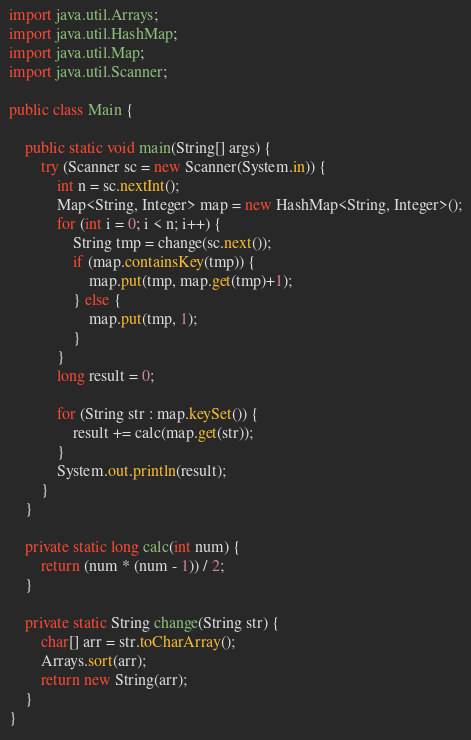Convert code to text. <code><loc_0><loc_0><loc_500><loc_500><_Java_>
import java.util.Arrays;
import java.util.HashMap;
import java.util.Map;
import java.util.Scanner;

public class Main {

	public static void main(String[] args) {
		try (Scanner sc = new Scanner(System.in)) {
			int n = sc.nextInt();
			Map<String, Integer> map = new HashMap<String, Integer>();
			for (int i = 0; i < n; i++) {
				String tmp = change(sc.next());
				if (map.containsKey(tmp)) {
					map.put(tmp, map.get(tmp)+1);
				} else {
					map.put(tmp, 1);
				}
			}
			long result = 0;

			for (String str : map.keySet()) {
				result += calc(map.get(str));
			}
			System.out.println(result);
		}
	}

	private static long calc(int num) {
		return (num * (num - 1)) / 2;
	}

	private static String change(String str) {
		char[] arr = str.toCharArray();
		Arrays.sort(arr);
		return new String(arr);
	}
}
</code> 